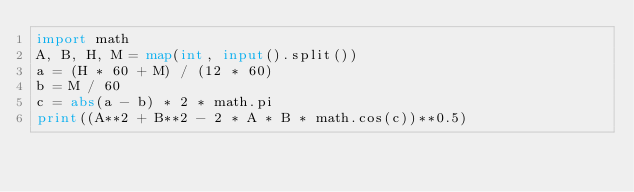Convert code to text. <code><loc_0><loc_0><loc_500><loc_500><_Python_>import math
A, B, H, M = map(int, input().split())
a = (H * 60 + M) / (12 * 60)
b = M / 60
c = abs(a - b) * 2 * math.pi
print((A**2 + B**2 - 2 * A * B * math.cos(c))**0.5)
</code> 